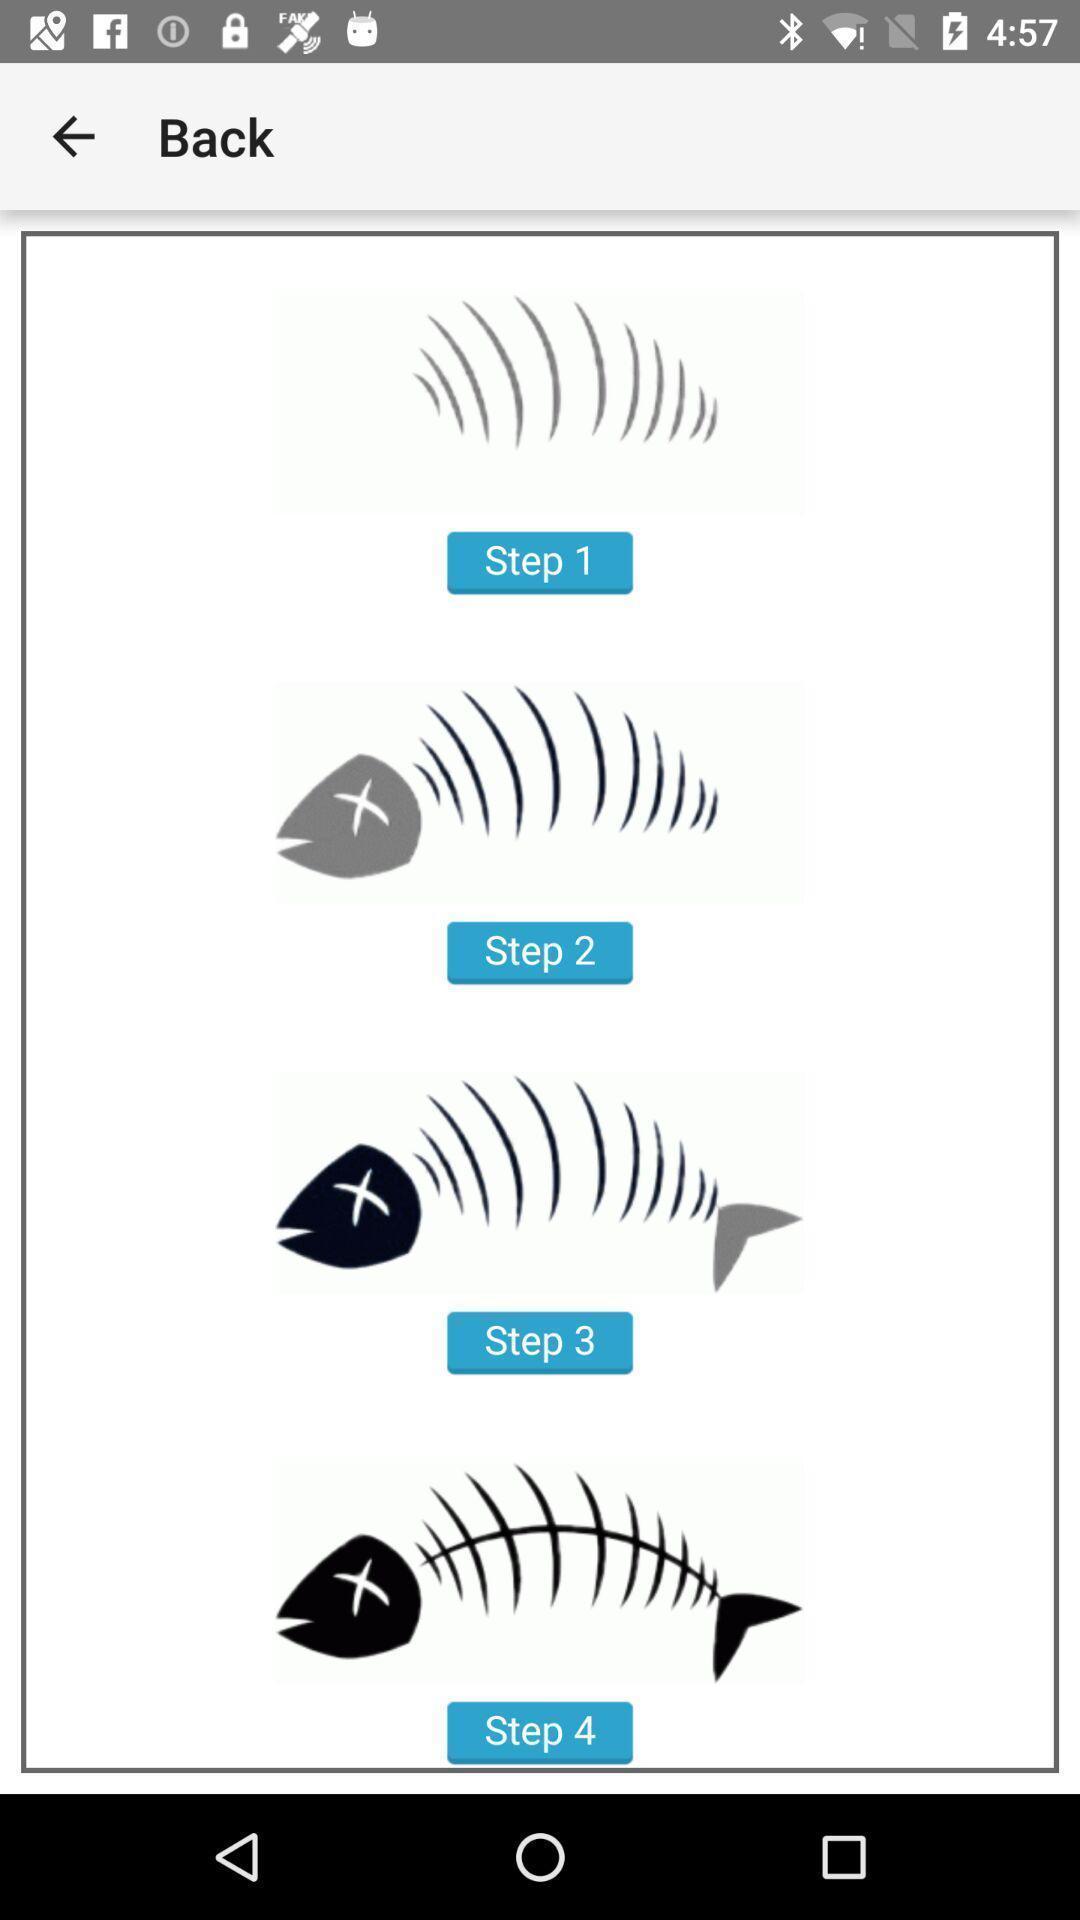Explain what's happening in this screen capture. Page showing various steps in app. 